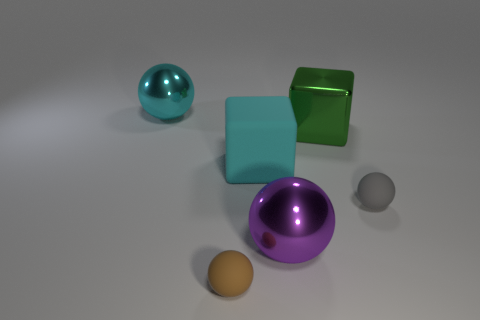Is the color of the large matte object the same as the large ball to the left of the rubber cube?
Your answer should be very brief. Yes. Are there any large objects that have the same color as the large rubber block?
Provide a succinct answer. Yes. What shape is the large metallic object that is the same color as the rubber block?
Give a very brief answer. Sphere. Are there any other things that have the same color as the metal block?
Your response must be concise. No. Is the material of the object that is in front of the purple metal thing the same as the gray sphere?
Offer a very short reply. Yes. Are there an equal number of brown things right of the large green metal cube and big rubber things that are in front of the brown rubber object?
Offer a terse response. Yes. How big is the rubber thing that is in front of the small matte sphere that is behind the tiny brown ball?
Ensure brevity in your answer.  Small. There is a big thing that is both right of the large cyan ball and left of the purple ball; what material is it made of?
Keep it short and to the point. Rubber. What number of other things are there of the same size as the cyan sphere?
Provide a short and direct response. 3. The large matte block is what color?
Give a very brief answer. Cyan. 